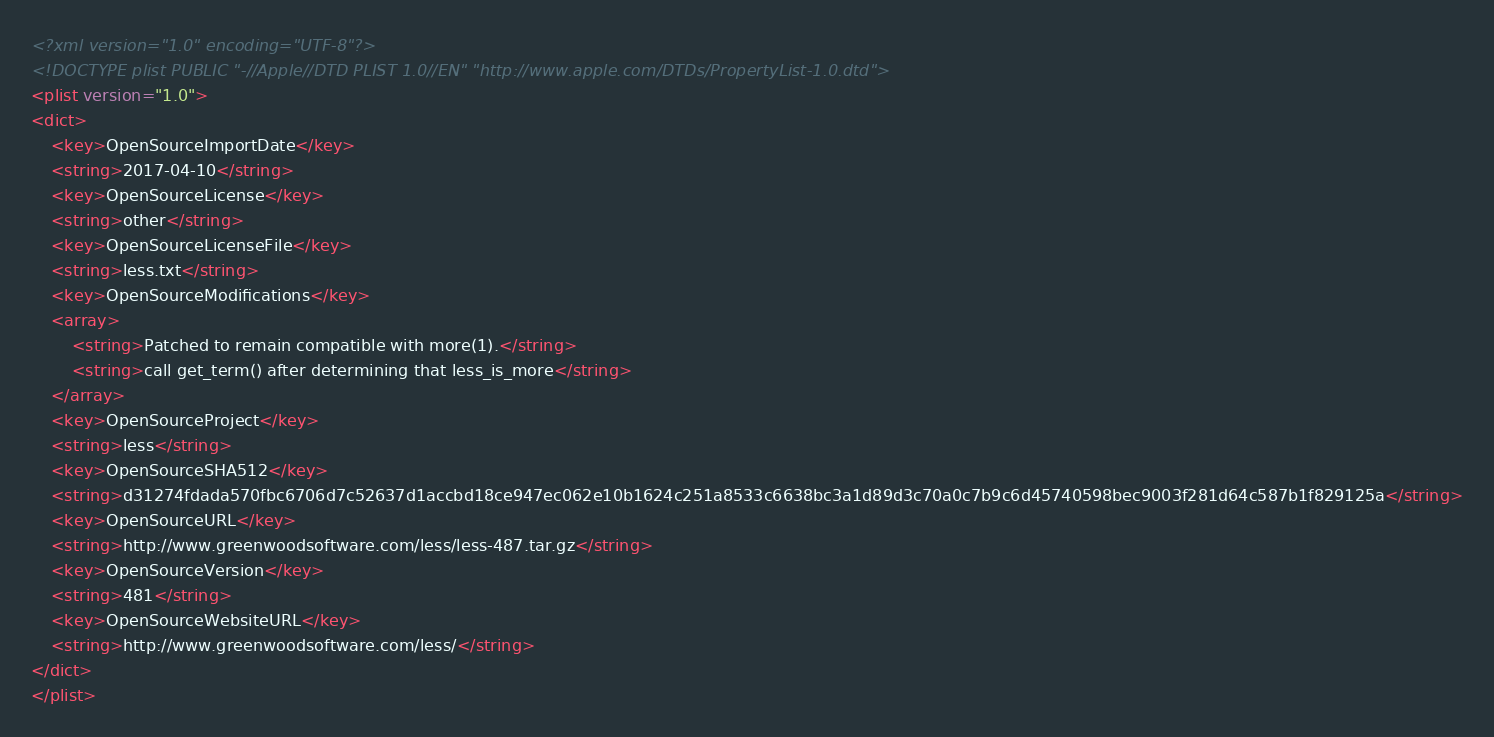Convert code to text. <code><loc_0><loc_0><loc_500><loc_500><_XML_><?xml version="1.0" encoding="UTF-8"?>
<!DOCTYPE plist PUBLIC "-//Apple//DTD PLIST 1.0//EN" "http://www.apple.com/DTDs/PropertyList-1.0.dtd">
<plist version="1.0">
<dict>
	<key>OpenSourceImportDate</key>
	<string>2017-04-10</string>
	<key>OpenSourceLicense</key>
	<string>other</string>
	<key>OpenSourceLicenseFile</key>
	<string>less.txt</string>
	<key>OpenSourceModifications</key>
	<array>
		<string>Patched to remain compatible with more(1).</string>
		<string>call get_term() after determining that less_is_more</string>
	</array>
	<key>OpenSourceProject</key>
	<string>less</string>
	<key>OpenSourceSHA512</key>
	<string>d31274fdada570fbc6706d7c52637d1accbd18ce947ec062e10b1624c251a8533c6638bc3a1d89d3c70a0c7b9c6d45740598bec9003f281d64c587b1f829125a</string>
	<key>OpenSourceURL</key>
	<string>http://www.greenwoodsoftware.com/less/less-487.tar.gz</string>
	<key>OpenSourceVersion</key>
	<string>481</string>
	<key>OpenSourceWebsiteURL</key>
	<string>http://www.greenwoodsoftware.com/less/</string>
</dict>
</plist>
</code> 